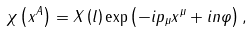<formula> <loc_0><loc_0><loc_500><loc_500>\chi \left ( x ^ { A } \right ) = X \left ( l \right ) \exp \left ( - i p _ { \mu } x ^ { \mu } + i n \varphi \right ) ,</formula> 